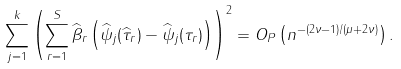<formula> <loc_0><loc_0><loc_500><loc_500>\sum _ { j = 1 } ^ { k } \left ( \sum _ { r = 1 } ^ { S } \widehat { \beta } _ { r } \left ( \widehat { \psi } _ { j } ( \widehat { \tau } _ { r } ) - \widehat { \psi } _ { j } ( \tau _ { r } ) \right ) \right ) ^ { 2 } = O _ { P } \left ( n ^ { - ( 2 \nu - 1 ) / ( \mu + 2 \nu ) } \right ) .</formula> 